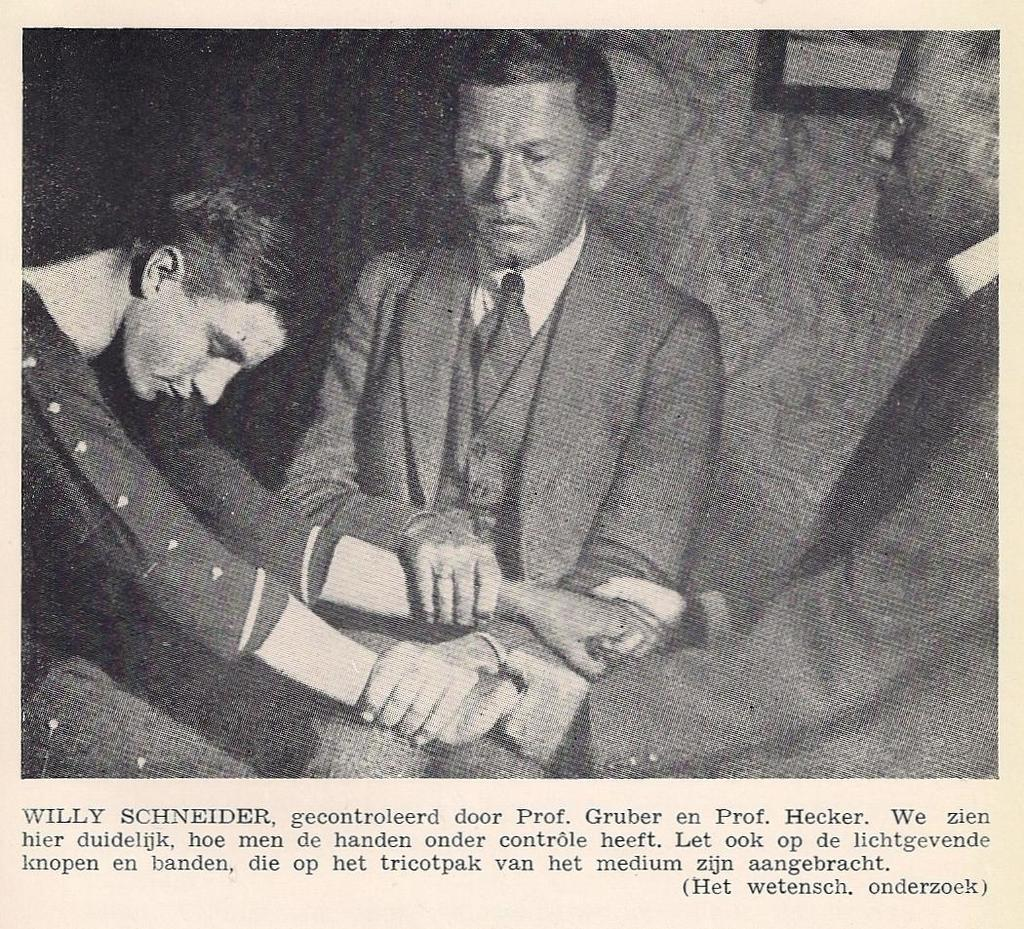What is the main object in the image? There is a paper in the image. What is depicted on the paper? There is a picture of three people on the paper. Is there any text on the paper? Yes, there is text at the bottom of the paper. What type of eggnog is being served at the event depicted in the image? There is no event or eggnog present in the image; it only features a paper with a picture of three people and text at the bottom. 